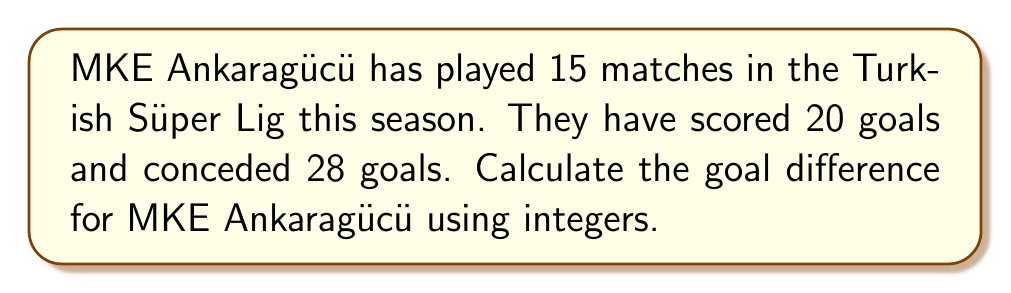Can you solve this math problem? To calculate the goal difference, we need to subtract the number of goals conceded from the number of goals scored. This can be represented using integers, where positive integers represent goals scored and negative integers represent goals conceded.

Let's break it down step by step:

1. Goals scored by MKE Ankaragücü: $+20$
2. Goals conceded by MKE Ankaragücü: $-28$

The goal difference is the sum of these two integers:

$$\text{Goal Difference} = (+20) + (-28)$$

Using the rules of integer addition:

$$\text{Goal Difference} = 20 - 28 = -8$$

The negative result indicates that MKE Ankaragücü has conceded more goals than they have scored.
Answer: $-8$ 